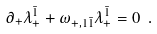Convert formula to latex. <formula><loc_0><loc_0><loc_500><loc_500>\partial _ { + } \lambda _ { + } ^ { \bar { 1 } } + \omega _ { + , 1 \bar { 1 } } \lambda _ { + } ^ { \bar { 1 } } = 0 \ .</formula> 